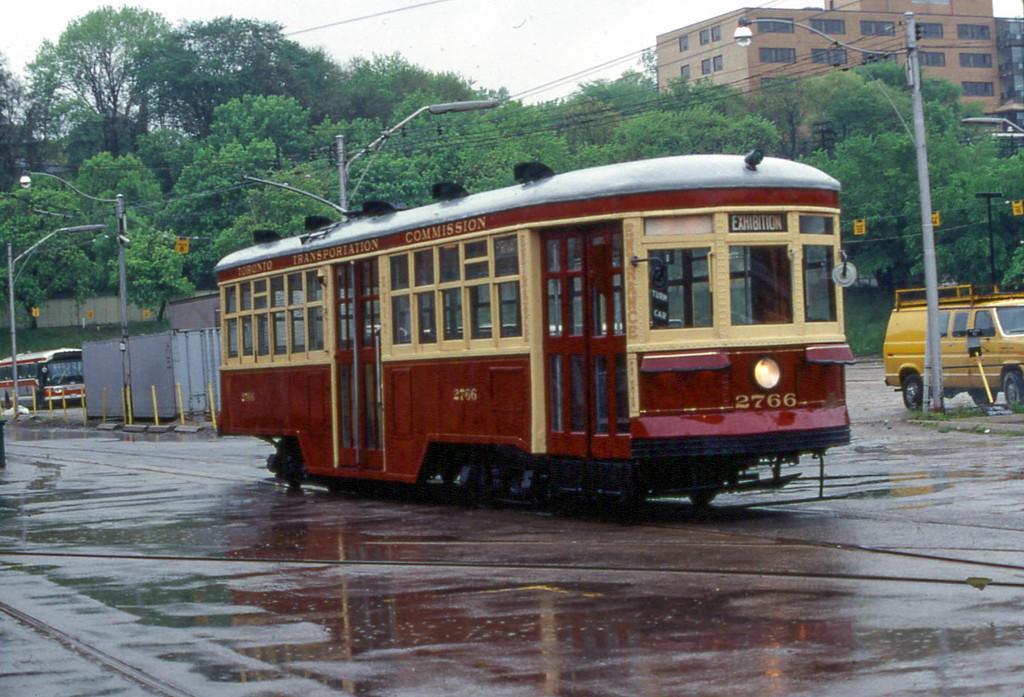Could you give a brief overview of what you see in this image? In this image we can see some vehicles on the road. We can also see some divider poles, a metal container, street poles, the sign boards, wires, a group of trees, a building with windows and the sky which looks cloudy. At the bottom of the image we can see some water on the road. 